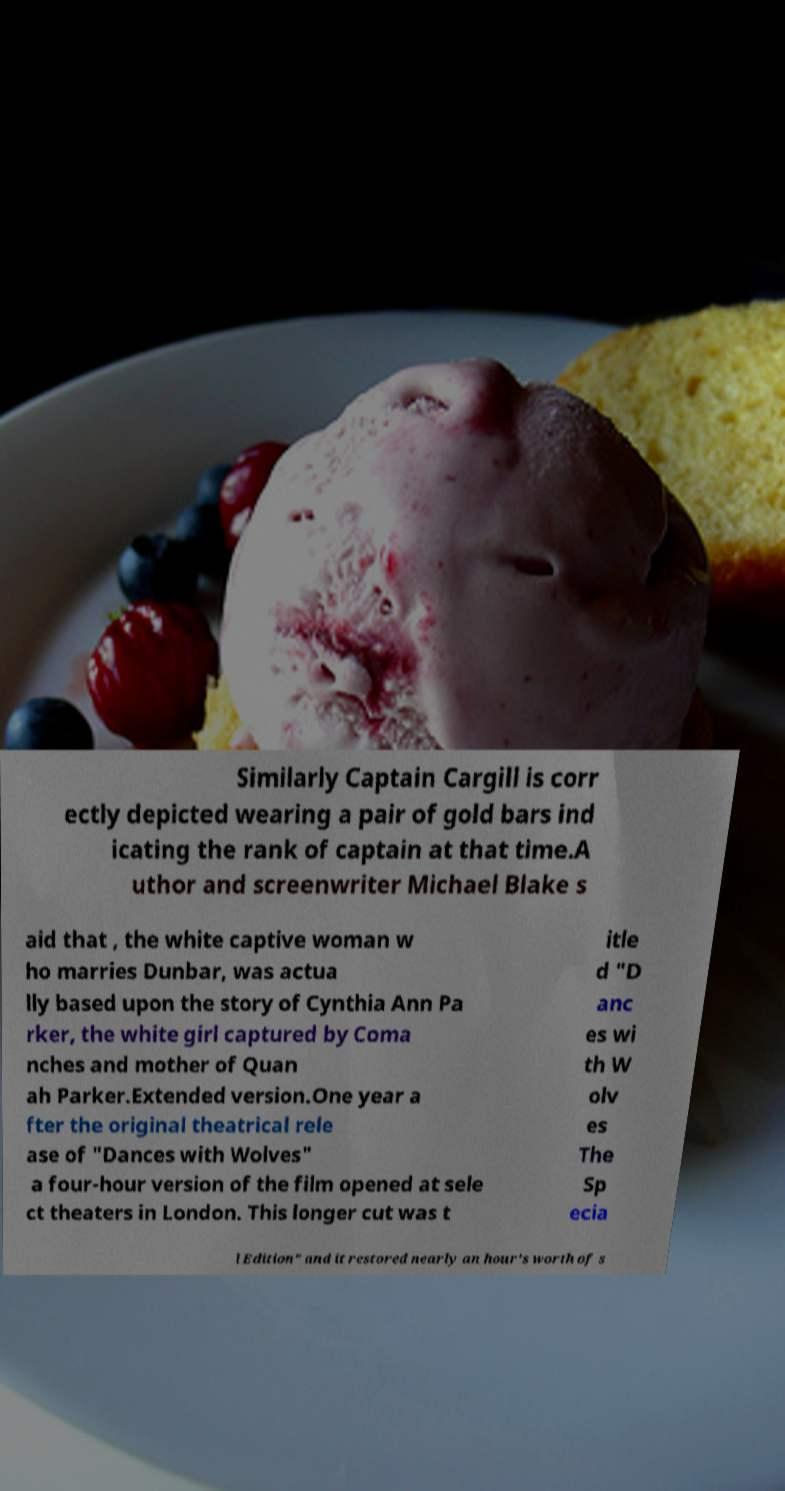What messages or text are displayed in this image? I need them in a readable, typed format. Similarly Captain Cargill is corr ectly depicted wearing a pair of gold bars ind icating the rank of captain at that time.A uthor and screenwriter Michael Blake s aid that , the white captive woman w ho marries Dunbar, was actua lly based upon the story of Cynthia Ann Pa rker, the white girl captured by Coma nches and mother of Quan ah Parker.Extended version.One year a fter the original theatrical rele ase of "Dances with Wolves" a four-hour version of the film opened at sele ct theaters in London. This longer cut was t itle d "D anc es wi th W olv es The Sp ecia l Edition" and it restored nearly an hour's worth of s 